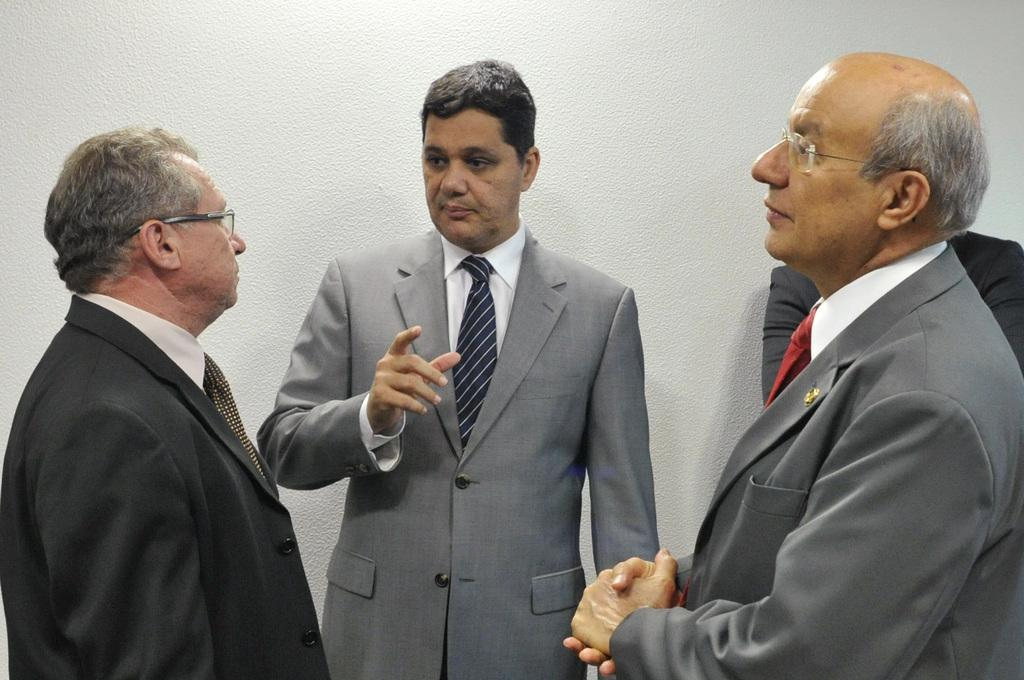How many individuals are present in the image? There are four people in the image. What is the position of the people in the image? The people are standing on the floor. What can be seen behind the people in the image? There is a white wall in the background of the image. What shape is the rake that the people are holding in the image? There is no rake present in the image, so it is not possible to determine its shape. 